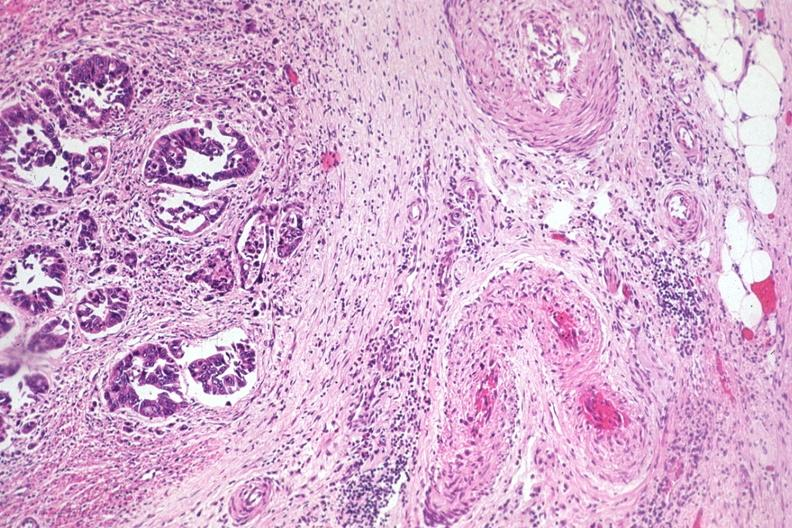what does this image show?
Answer the question using a single word or phrase. Typical infiltrating adenocarcinoma extending to serosal fat 